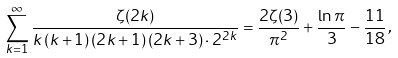<formula> <loc_0><loc_0><loc_500><loc_500>\sum _ { k = 1 } ^ { \infty } { \frac { \zeta ( 2 k ) } { k \, ( k + 1 ) \, ( 2 k + 1 ) \, ( 2 k + 3 ) \cdot 2 ^ { 2 k } } } = \frac { 2 \zeta ( 3 ) } { \pi ^ { 2 } } + \frac { \ln { \pi } } { 3 } - \frac { 1 1 } { 1 8 } \, ,</formula> 